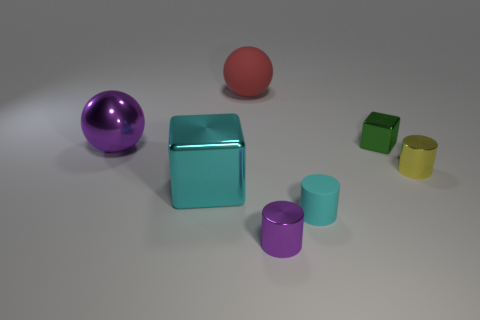Add 2 large yellow spheres. How many objects exist? 9 Subtract all cubes. How many objects are left? 5 Subtract 0 brown cubes. How many objects are left? 7 Subtract all big metal things. Subtract all big purple metallic spheres. How many objects are left? 4 Add 2 matte balls. How many matte balls are left? 3 Add 3 large things. How many large things exist? 6 